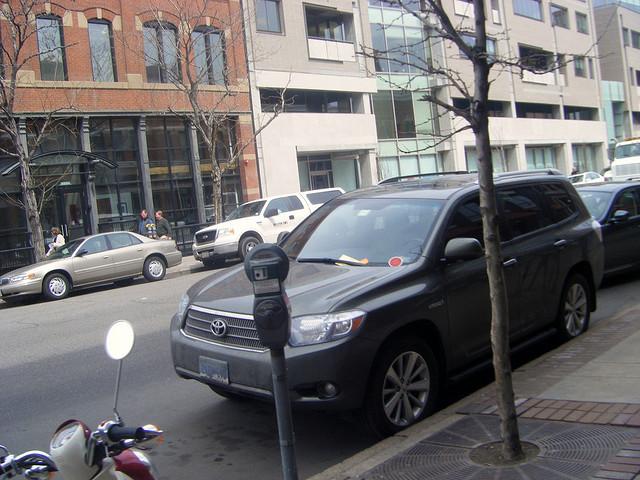What type of vehicle is partly visible in the foreground?
Quick response, please. Motorcycle. What make is the main car?
Answer briefly. Toyota. Are the cars parked?
Give a very brief answer. Yes. 